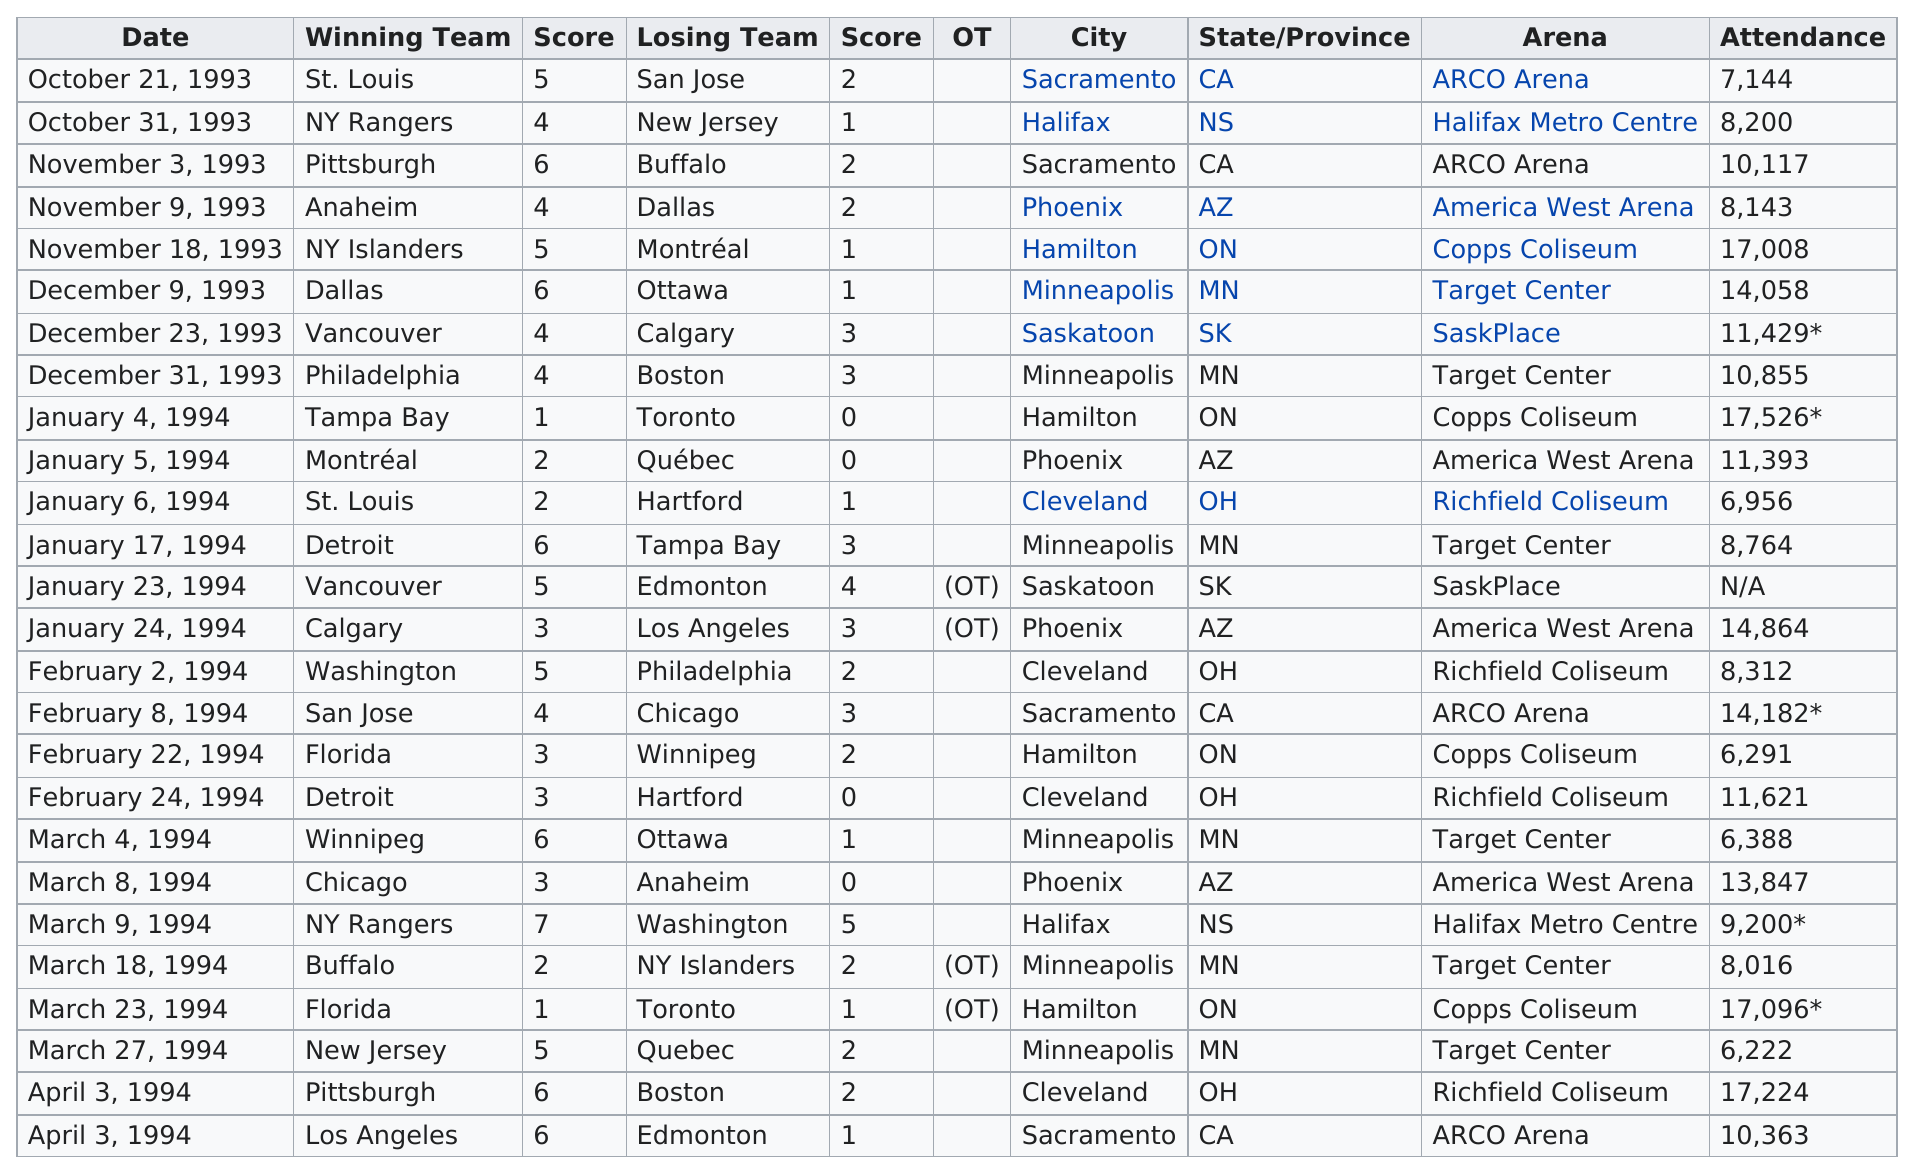Specify some key components in this picture. On the day before the January 5, 1994 game, Tampa Bay won the game. The attendance at the November 18, 1993 games was higher by 8,865 people than the November 9th game. To date, a total of 6 games have been held in Minneapolis. Out of the total number of events, four events had attendance above 17,000 attendees. The game that had the most attendance was on January 4, 1994. 